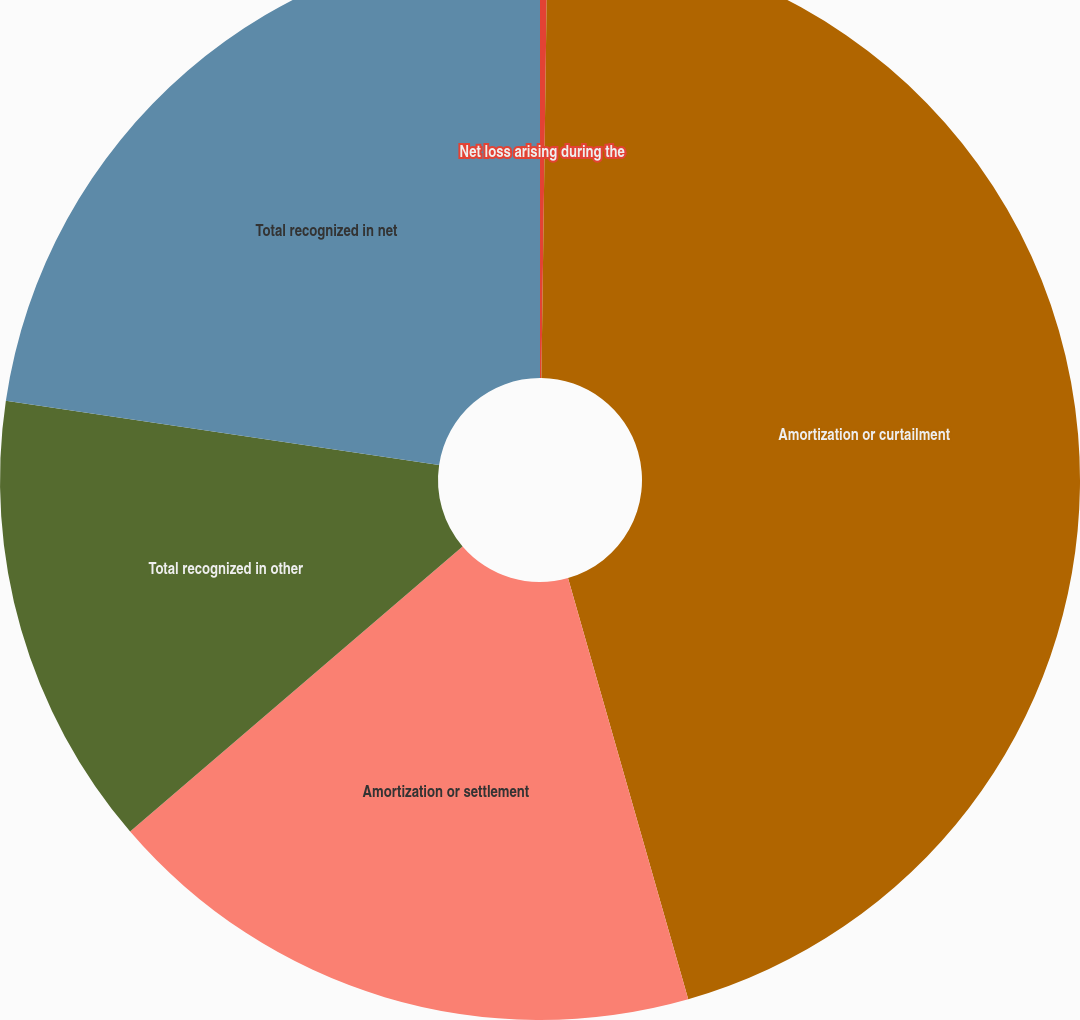Convert chart to OTSL. <chart><loc_0><loc_0><loc_500><loc_500><pie_chart><fcel>Net loss arising during the<fcel>Amortization or curtailment<fcel>Amortization or settlement<fcel>Total recognized in other<fcel>Total recognized in net<nl><fcel>0.22%<fcel>45.35%<fcel>18.14%<fcel>13.63%<fcel>22.65%<nl></chart> 